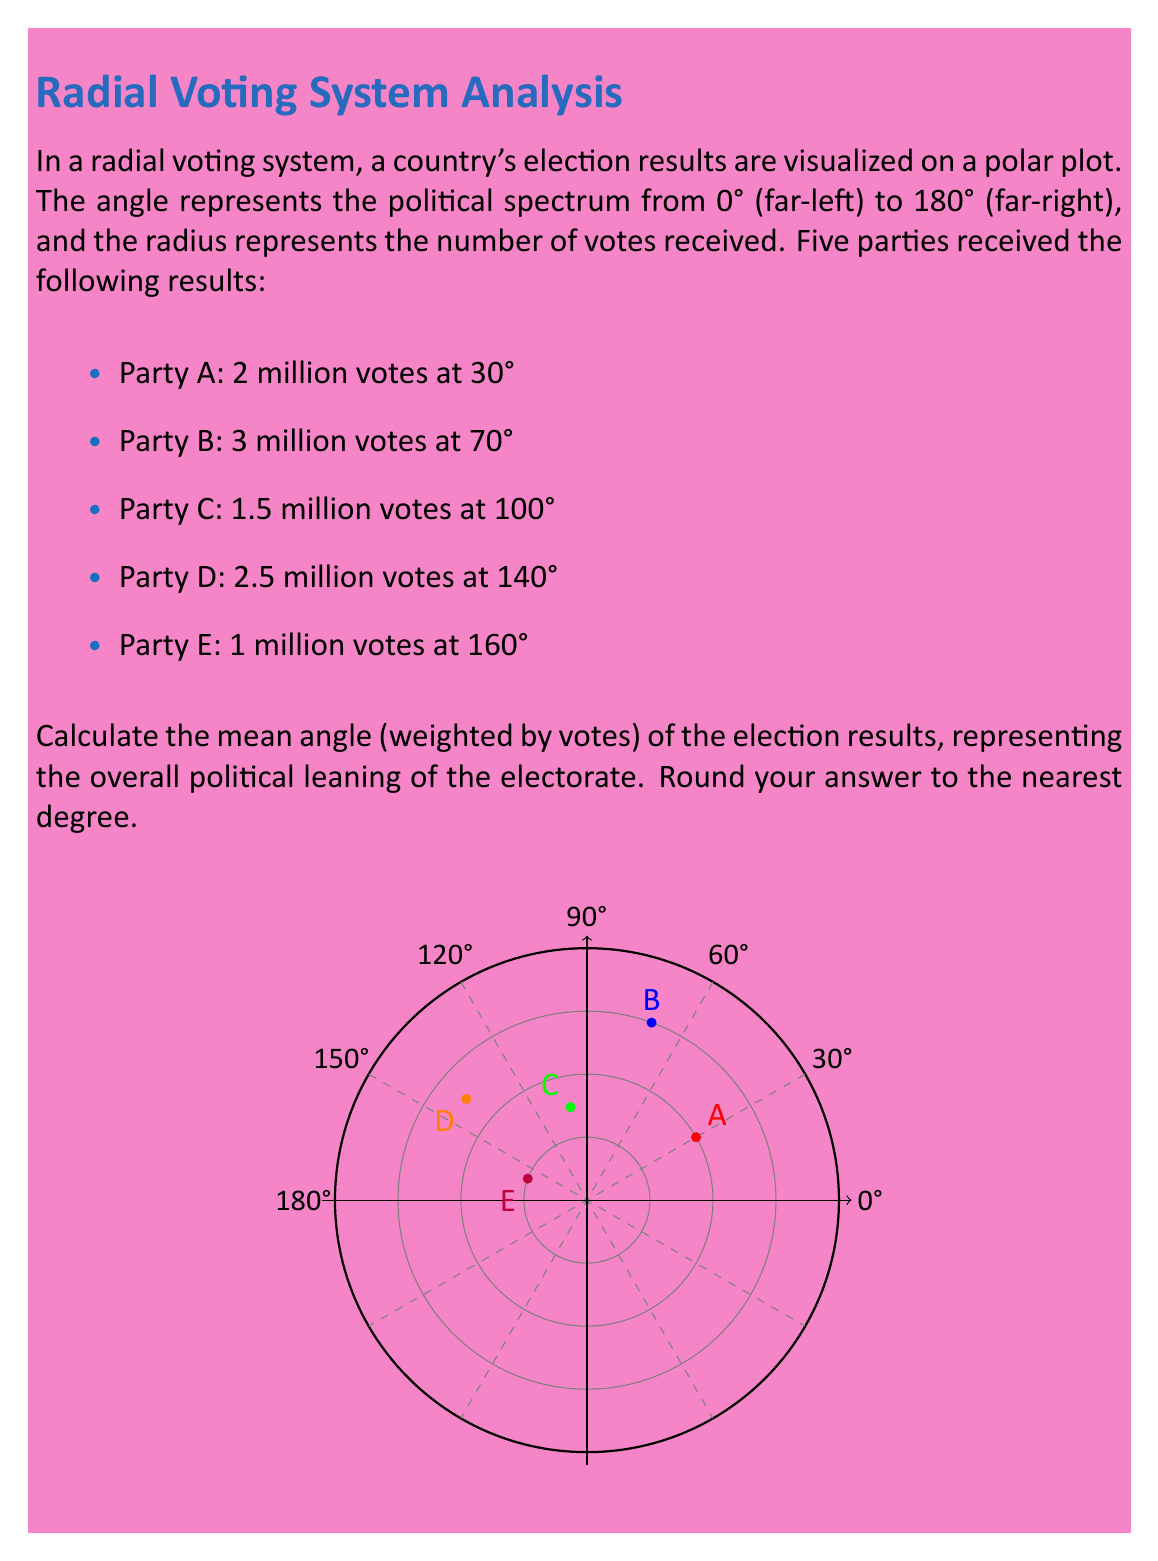Teach me how to tackle this problem. To calculate the weighted mean angle, we'll use the formula for the angle of the resultant vector in polar coordinates:

$$\theta = \arctan2\left(\frac{\sum_{i=1}^n r_i \sin\theta_i}{\sum_{i=1}^n r_i \cos\theta_i}\right)$$

Where $r_i$ is the number of votes (in millions) and $\theta_i$ is the angle for each party.

Step 1: Calculate $\sum_{i=1}^n r_i \sin\theta_i$
$2 \sin(30°) + 3 \sin(70°) + 1.5 \sin(100°) + 2.5 \sin(140°) + 1 \sin(160°)$
$= 1 + 2.82 + 1.48 + 1.91 + 0.34 = 7.55$

Step 2: Calculate $\sum_{i=1}^n r_i \cos\theta_i$
$2 \cos(30°) + 3 \cos(70°) + 1.5 \cos(100°) + 2.5 \cos(140°) + 1 \cos(160°)$
$= 1.73 + 1.03 - 0.26 - 1.91 - 0.94 = -0.35$

Step 3: Calculate $\arctan2(7.55, -0.35)$
$\theta = \arctan2(7.55, -0.35) \approx 92.65°$

Step 4: Round to the nearest degree
$92.65° \approx 93°$
Answer: 93° 